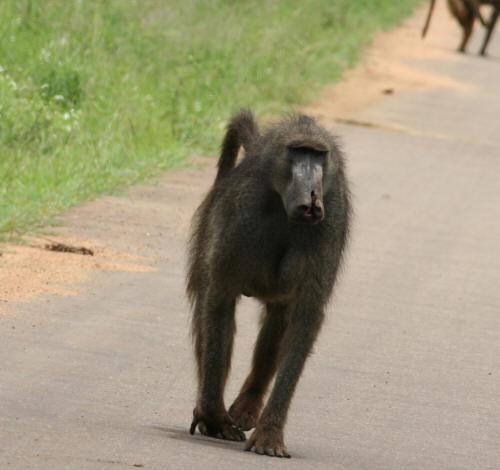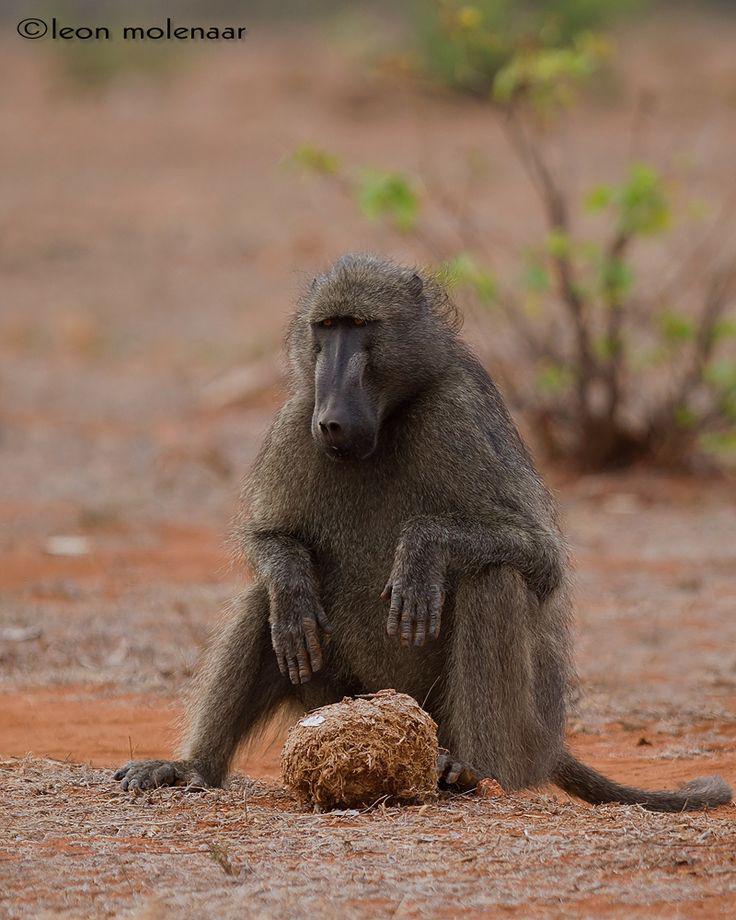The first image is the image on the left, the second image is the image on the right. Evaluate the accuracy of this statement regarding the images: "The right image contains at least two monkeys.". Is it true? Answer yes or no. No. The first image is the image on the left, the second image is the image on the right. Given the left and right images, does the statement "A baby baboon is clinging to an adult baboon walking on all fours in one image, and each image contains at least one baby baboon." hold true? Answer yes or no. No. 